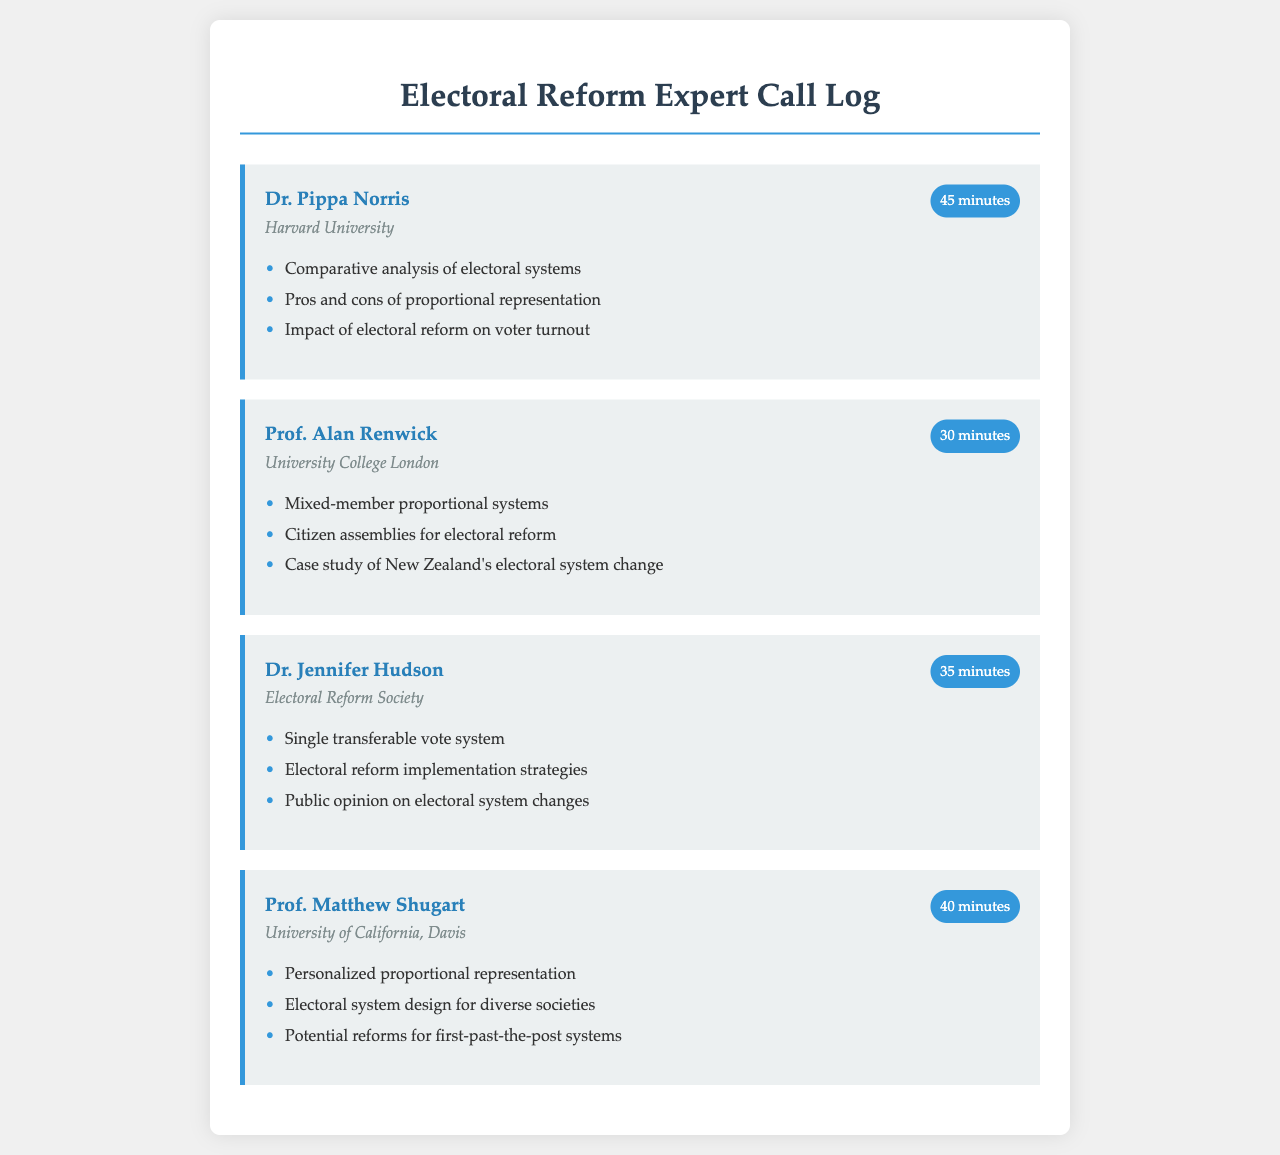What is the name of the first expert? The first expert listed in the document is Dr. Pippa Norris.
Answer: Dr. Pippa Norris Which organization does Prof. Alan Renwick belong to? Prof. Alan Renwick is associated with University College London.
Answer: University College London How long was the call with Dr. Jennifer Hudson? The duration of the call with Dr. Jennifer Hudson was 35 minutes.
Answer: 35 minutes What electoral system topic did Prof. Matthew Shugart discuss? Prof. Matthew Shugart discussed personalized proportional representation.
Answer: Personalized proportional representation What was a key topic during the call with Dr. Pippa Norris? A key topic discussed with Dr. Pippa Norris was the impact of electoral reform on voter turnout.
Answer: Impact of electoral reform on voter turnout How many minutes did the call with Prof. Matthew Shugart last? The call with Prof. Matthew Shugart lasted for 40 minutes.
Answer: 40 minutes Which expert discussed public opinion on electoral system changes? Dr. Jennifer Hudson discussed public opinion on electoral system changes.
Answer: Dr. Jennifer Hudson What was a common theme in the discussions? A common theme was various electoral system reforms and their implications.
Answer: Electoral system reforms What duration indicates the shortest call recorded? The shortest call recorded was 30 minutes.
Answer: 30 minutes 